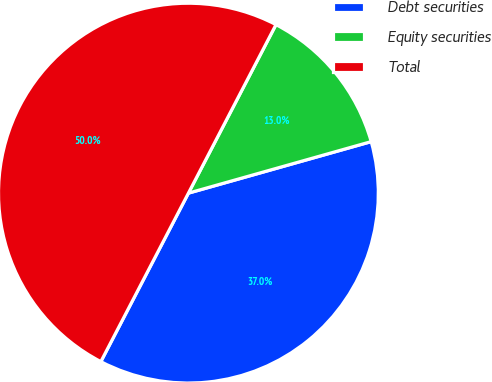<chart> <loc_0><loc_0><loc_500><loc_500><pie_chart><fcel>Debt securities<fcel>Equity securities<fcel>Total<nl><fcel>37.0%<fcel>13.0%<fcel>50.0%<nl></chart> 